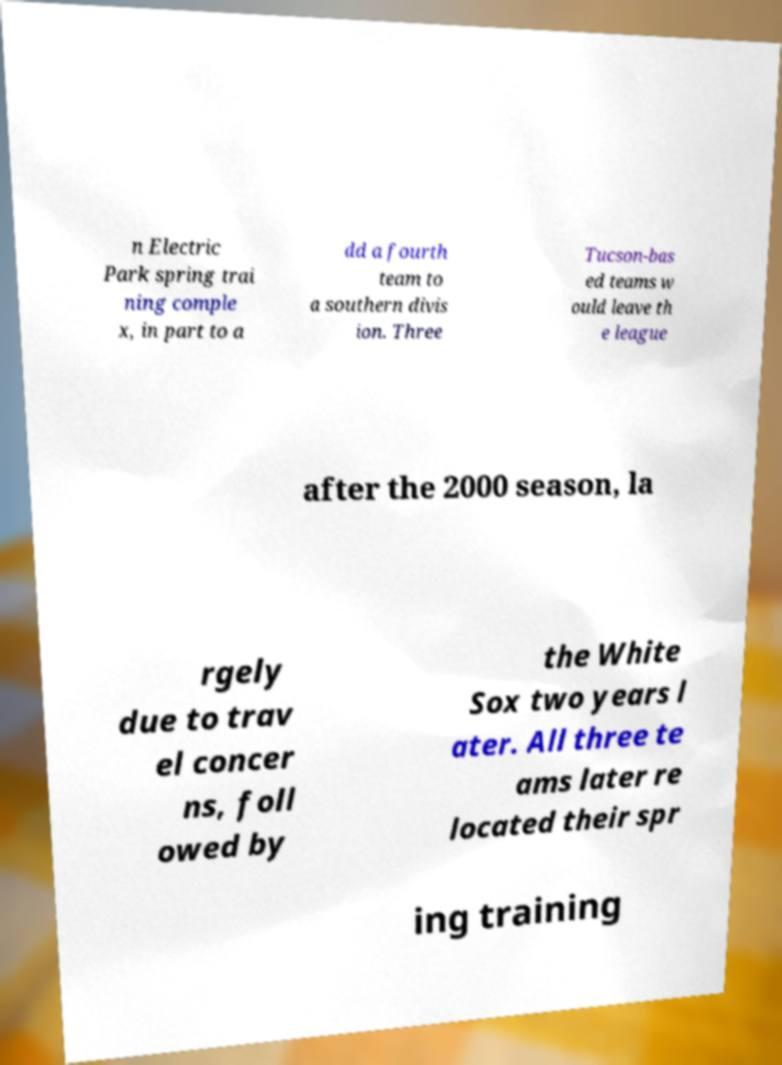Could you extract and type out the text from this image? n Electric Park spring trai ning comple x, in part to a dd a fourth team to a southern divis ion. Three Tucson-bas ed teams w ould leave th e league after the 2000 season, la rgely due to trav el concer ns, foll owed by the White Sox two years l ater. All three te ams later re located their spr ing training 